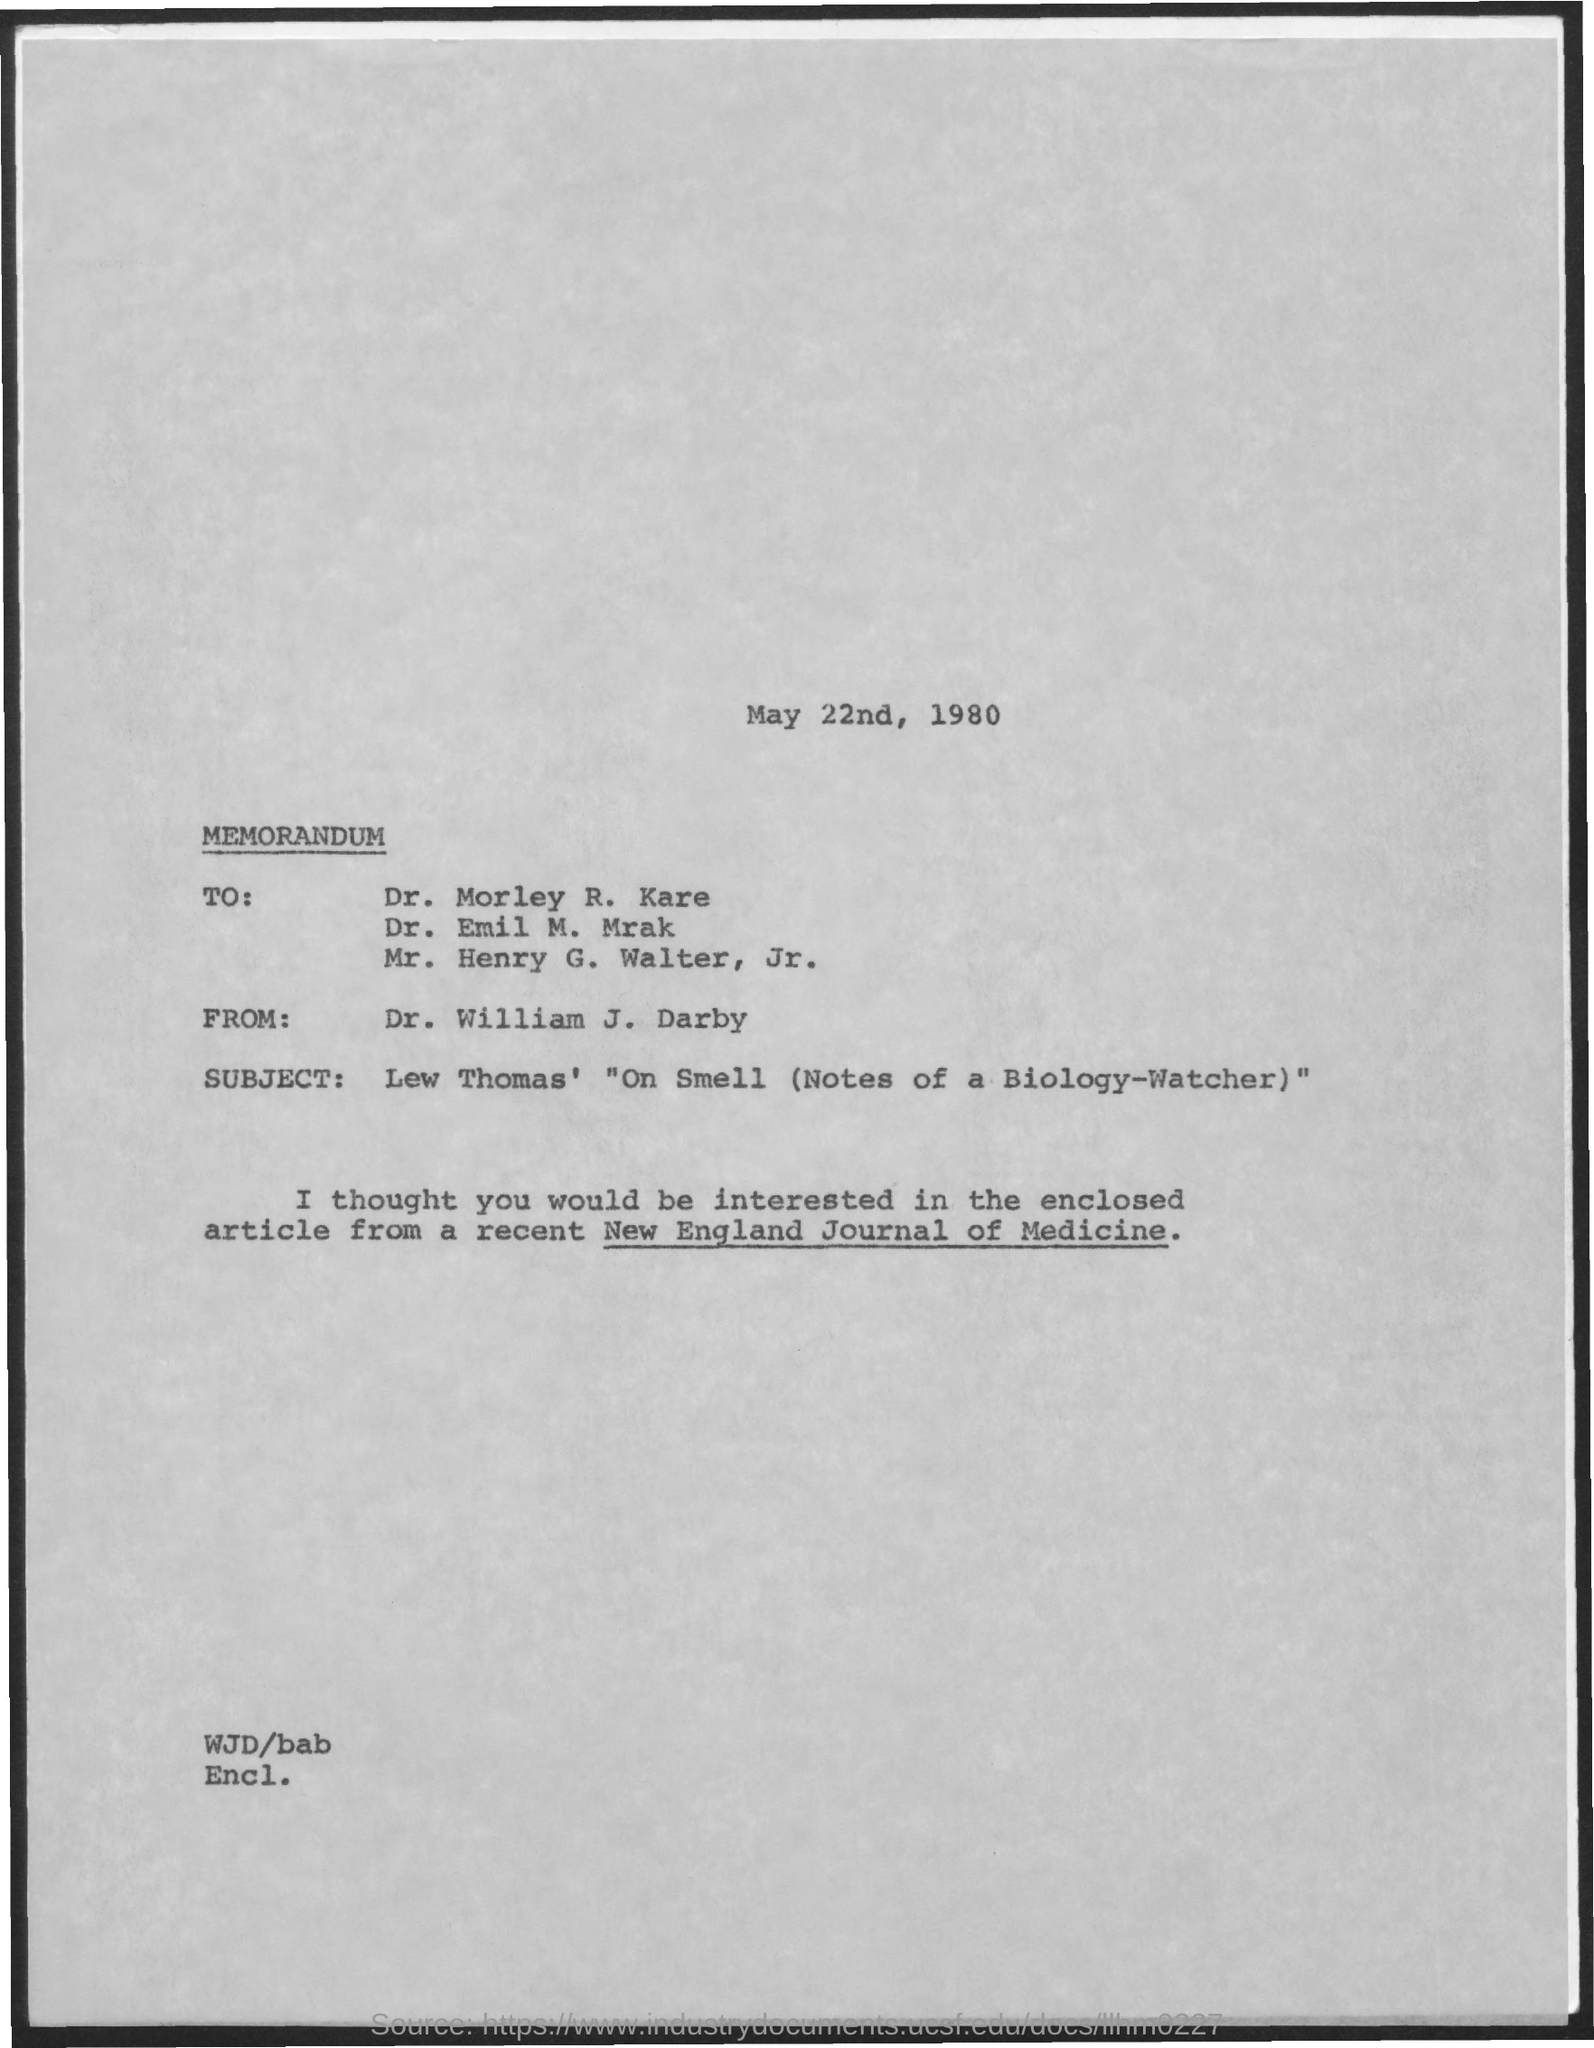Outline some significant characteristics in this image. The date mentioned in the document is May 22nd, 1980. The memorandum is from Dr. William J. Darby. 